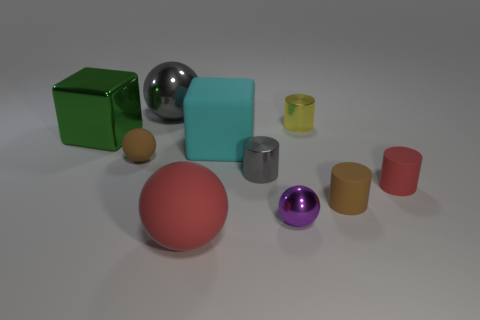Subtract all red matte cylinders. How many cylinders are left? 3 Subtract all brown balls. How many balls are left? 3 Subtract 3 balls. How many balls are left? 1 Subtract all red spheres. How many green blocks are left? 1 Subtract 0 green balls. How many objects are left? 10 Subtract all blocks. How many objects are left? 8 Subtract all green blocks. Subtract all red spheres. How many blocks are left? 1 Subtract all red matte cylinders. Subtract all blue rubber cylinders. How many objects are left? 9 Add 5 red things. How many red things are left? 7 Add 8 red cubes. How many red cubes exist? 8 